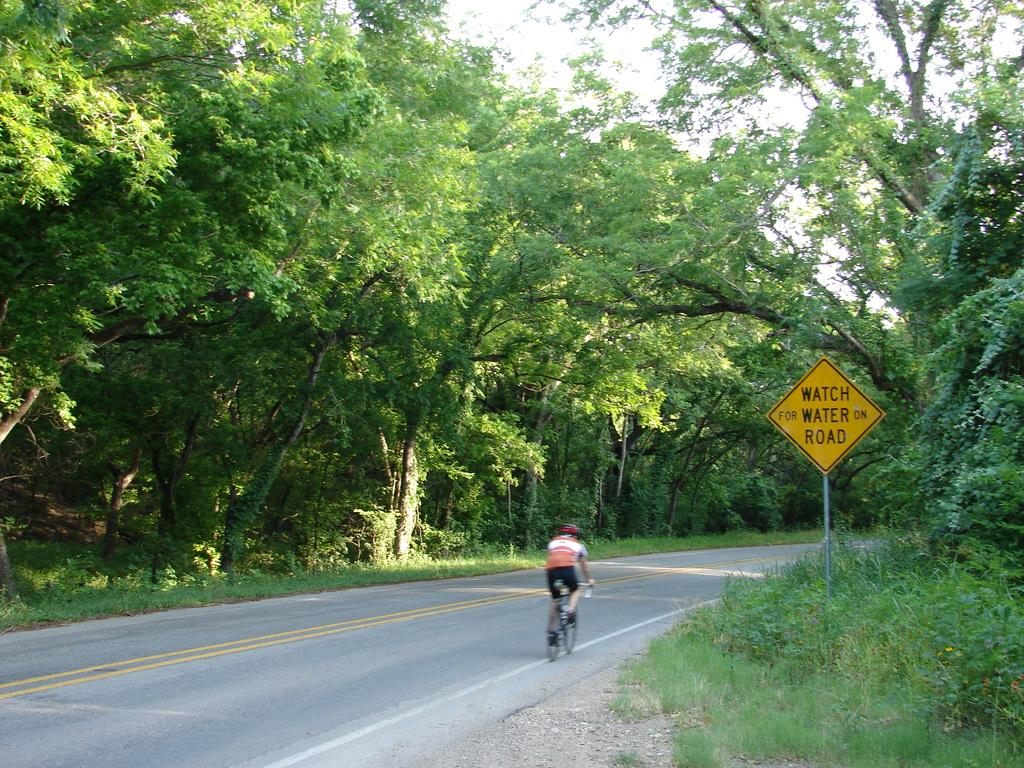What is the person in the image doing? The person is riding a bicycle in the image. Where is the person riding the bicycle? The person is on the road. What can be seen in the background of the image? There are trees and plants in the image. What is the board with text used for in the image? The purpose of the board with text is not clear from the image, but it is present. What type of nail is being used to join the yoke to the bicycle in the image? There is no nail or yoke present in the image; it features a person riding a bicycle on the road with trees and plants in the background. 